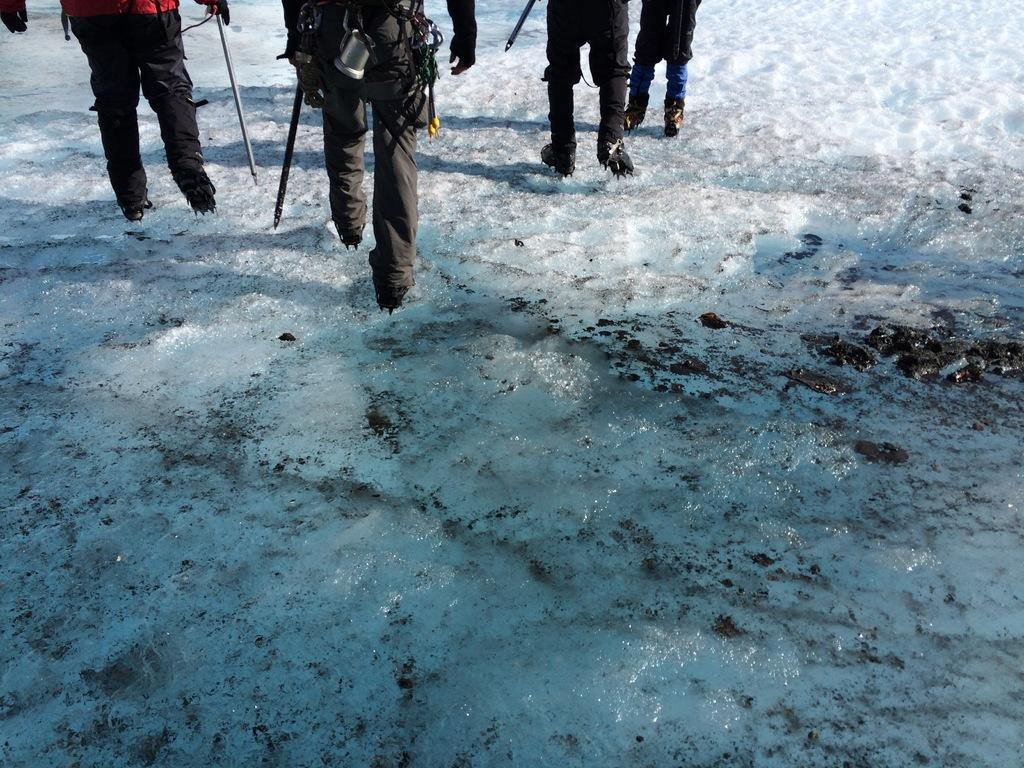What are the persons in the image doing? The persons in the image are walking on the snow. What are the persons holding in the image? The persons are holding objects. What type of terrain is visible at the bottom of the image? There is ice visible at the bottom of the image. What type of crate can be seen in the image? There is no crate present in the image. What color is the bulb that is illuminating the scene? There is no bulb present in the image; the scene is outdoors and illuminated by natural light. 